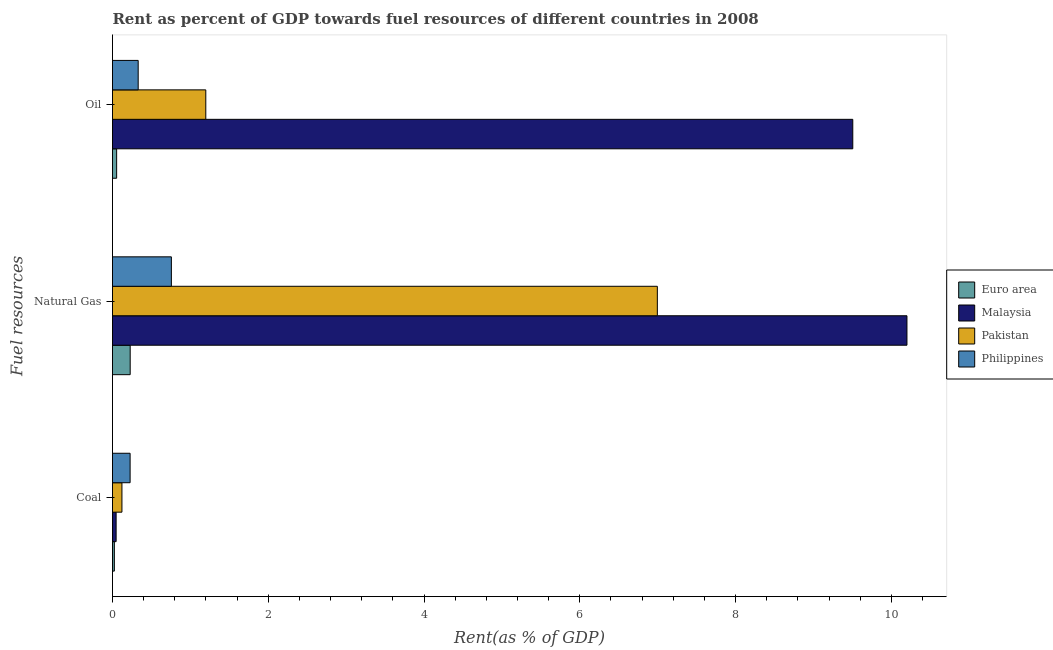How many different coloured bars are there?
Provide a succinct answer. 4. How many groups of bars are there?
Your answer should be very brief. 3. How many bars are there on the 2nd tick from the top?
Your response must be concise. 4. What is the label of the 2nd group of bars from the top?
Keep it short and to the point. Natural Gas. What is the rent towards natural gas in Euro area?
Ensure brevity in your answer.  0.23. Across all countries, what is the maximum rent towards coal?
Offer a terse response. 0.23. Across all countries, what is the minimum rent towards natural gas?
Your answer should be compact. 0.23. In which country was the rent towards natural gas maximum?
Keep it short and to the point. Malaysia. In which country was the rent towards natural gas minimum?
Your response must be concise. Euro area. What is the total rent towards oil in the graph?
Offer a very short reply. 11.09. What is the difference between the rent towards oil in Pakistan and that in Euro area?
Make the answer very short. 1.14. What is the difference between the rent towards oil in Euro area and the rent towards natural gas in Philippines?
Make the answer very short. -0.7. What is the average rent towards natural gas per country?
Ensure brevity in your answer.  4.54. What is the difference between the rent towards oil and rent towards natural gas in Euro area?
Offer a terse response. -0.17. What is the ratio of the rent towards oil in Malaysia to that in Philippines?
Your response must be concise. 28.83. Is the rent towards oil in Malaysia less than that in Euro area?
Ensure brevity in your answer.  No. Is the difference between the rent towards coal in Pakistan and Philippines greater than the difference between the rent towards natural gas in Pakistan and Philippines?
Your response must be concise. No. What is the difference between the highest and the second highest rent towards natural gas?
Your answer should be compact. 3.2. What is the difference between the highest and the lowest rent towards oil?
Your answer should be very brief. 9.45. In how many countries, is the rent towards coal greater than the average rent towards coal taken over all countries?
Keep it short and to the point. 2. Is the sum of the rent towards natural gas in Euro area and Malaysia greater than the maximum rent towards coal across all countries?
Offer a terse response. Yes. What does the 4th bar from the top in Natural Gas represents?
Provide a short and direct response. Euro area. Is it the case that in every country, the sum of the rent towards coal and rent towards natural gas is greater than the rent towards oil?
Provide a succinct answer. Yes. How many countries are there in the graph?
Give a very brief answer. 4. What is the difference between two consecutive major ticks on the X-axis?
Keep it short and to the point. 2. Does the graph contain any zero values?
Keep it short and to the point. No. Does the graph contain grids?
Provide a succinct answer. No. What is the title of the graph?
Keep it short and to the point. Rent as percent of GDP towards fuel resources of different countries in 2008. What is the label or title of the X-axis?
Your answer should be compact. Rent(as % of GDP). What is the label or title of the Y-axis?
Your answer should be compact. Fuel resources. What is the Rent(as % of GDP) of Euro area in Coal?
Your answer should be compact. 0.02. What is the Rent(as % of GDP) in Malaysia in Coal?
Your response must be concise. 0.05. What is the Rent(as % of GDP) of Pakistan in Coal?
Make the answer very short. 0.12. What is the Rent(as % of GDP) of Philippines in Coal?
Your response must be concise. 0.23. What is the Rent(as % of GDP) in Euro area in Natural Gas?
Your answer should be compact. 0.23. What is the Rent(as % of GDP) of Malaysia in Natural Gas?
Ensure brevity in your answer.  10.2. What is the Rent(as % of GDP) in Pakistan in Natural Gas?
Your answer should be compact. 7. What is the Rent(as % of GDP) of Philippines in Natural Gas?
Your answer should be compact. 0.76. What is the Rent(as % of GDP) in Euro area in Oil?
Make the answer very short. 0.05. What is the Rent(as % of GDP) in Malaysia in Oil?
Keep it short and to the point. 9.5. What is the Rent(as % of GDP) in Pakistan in Oil?
Your answer should be very brief. 1.2. What is the Rent(as % of GDP) of Philippines in Oil?
Keep it short and to the point. 0.33. Across all Fuel resources, what is the maximum Rent(as % of GDP) of Euro area?
Make the answer very short. 0.23. Across all Fuel resources, what is the maximum Rent(as % of GDP) in Malaysia?
Provide a succinct answer. 10.2. Across all Fuel resources, what is the maximum Rent(as % of GDP) of Pakistan?
Make the answer very short. 7. Across all Fuel resources, what is the maximum Rent(as % of GDP) of Philippines?
Your answer should be compact. 0.76. Across all Fuel resources, what is the minimum Rent(as % of GDP) of Euro area?
Offer a very short reply. 0.02. Across all Fuel resources, what is the minimum Rent(as % of GDP) of Malaysia?
Your answer should be very brief. 0.05. Across all Fuel resources, what is the minimum Rent(as % of GDP) of Pakistan?
Ensure brevity in your answer.  0.12. Across all Fuel resources, what is the minimum Rent(as % of GDP) of Philippines?
Give a very brief answer. 0.23. What is the total Rent(as % of GDP) of Euro area in the graph?
Offer a very short reply. 0.3. What is the total Rent(as % of GDP) in Malaysia in the graph?
Your answer should be very brief. 19.75. What is the total Rent(as % of GDP) of Pakistan in the graph?
Offer a terse response. 8.31. What is the total Rent(as % of GDP) of Philippines in the graph?
Your answer should be compact. 1.31. What is the difference between the Rent(as % of GDP) in Euro area in Coal and that in Natural Gas?
Provide a short and direct response. -0.2. What is the difference between the Rent(as % of GDP) in Malaysia in Coal and that in Natural Gas?
Your response must be concise. -10.15. What is the difference between the Rent(as % of GDP) in Pakistan in Coal and that in Natural Gas?
Your answer should be very brief. -6.87. What is the difference between the Rent(as % of GDP) of Philippines in Coal and that in Natural Gas?
Give a very brief answer. -0.53. What is the difference between the Rent(as % of GDP) of Euro area in Coal and that in Oil?
Offer a terse response. -0.03. What is the difference between the Rent(as % of GDP) in Malaysia in Coal and that in Oil?
Offer a terse response. -9.46. What is the difference between the Rent(as % of GDP) in Pakistan in Coal and that in Oil?
Provide a succinct answer. -1.08. What is the difference between the Rent(as % of GDP) of Philippines in Coal and that in Oil?
Offer a very short reply. -0.1. What is the difference between the Rent(as % of GDP) of Euro area in Natural Gas and that in Oil?
Your answer should be compact. 0.17. What is the difference between the Rent(as % of GDP) of Malaysia in Natural Gas and that in Oil?
Your response must be concise. 0.7. What is the difference between the Rent(as % of GDP) of Pakistan in Natural Gas and that in Oil?
Your answer should be very brief. 5.8. What is the difference between the Rent(as % of GDP) of Philippines in Natural Gas and that in Oil?
Give a very brief answer. 0.43. What is the difference between the Rent(as % of GDP) in Euro area in Coal and the Rent(as % of GDP) in Malaysia in Natural Gas?
Your answer should be compact. -10.18. What is the difference between the Rent(as % of GDP) of Euro area in Coal and the Rent(as % of GDP) of Pakistan in Natural Gas?
Give a very brief answer. -6.97. What is the difference between the Rent(as % of GDP) in Euro area in Coal and the Rent(as % of GDP) in Philippines in Natural Gas?
Your answer should be very brief. -0.73. What is the difference between the Rent(as % of GDP) in Malaysia in Coal and the Rent(as % of GDP) in Pakistan in Natural Gas?
Provide a succinct answer. -6.95. What is the difference between the Rent(as % of GDP) of Malaysia in Coal and the Rent(as % of GDP) of Philippines in Natural Gas?
Provide a short and direct response. -0.71. What is the difference between the Rent(as % of GDP) in Pakistan in Coal and the Rent(as % of GDP) in Philippines in Natural Gas?
Keep it short and to the point. -0.63. What is the difference between the Rent(as % of GDP) in Euro area in Coal and the Rent(as % of GDP) in Malaysia in Oil?
Your answer should be compact. -9.48. What is the difference between the Rent(as % of GDP) of Euro area in Coal and the Rent(as % of GDP) of Pakistan in Oil?
Provide a short and direct response. -1.17. What is the difference between the Rent(as % of GDP) of Euro area in Coal and the Rent(as % of GDP) of Philippines in Oil?
Your answer should be very brief. -0.31. What is the difference between the Rent(as % of GDP) of Malaysia in Coal and the Rent(as % of GDP) of Pakistan in Oil?
Your answer should be very brief. -1.15. What is the difference between the Rent(as % of GDP) of Malaysia in Coal and the Rent(as % of GDP) of Philippines in Oil?
Keep it short and to the point. -0.28. What is the difference between the Rent(as % of GDP) of Pakistan in Coal and the Rent(as % of GDP) of Philippines in Oil?
Keep it short and to the point. -0.21. What is the difference between the Rent(as % of GDP) in Euro area in Natural Gas and the Rent(as % of GDP) in Malaysia in Oil?
Your response must be concise. -9.28. What is the difference between the Rent(as % of GDP) of Euro area in Natural Gas and the Rent(as % of GDP) of Pakistan in Oil?
Provide a succinct answer. -0.97. What is the difference between the Rent(as % of GDP) in Euro area in Natural Gas and the Rent(as % of GDP) in Philippines in Oil?
Your answer should be compact. -0.1. What is the difference between the Rent(as % of GDP) of Malaysia in Natural Gas and the Rent(as % of GDP) of Pakistan in Oil?
Give a very brief answer. 9. What is the difference between the Rent(as % of GDP) of Malaysia in Natural Gas and the Rent(as % of GDP) of Philippines in Oil?
Give a very brief answer. 9.87. What is the difference between the Rent(as % of GDP) in Pakistan in Natural Gas and the Rent(as % of GDP) in Philippines in Oil?
Your response must be concise. 6.67. What is the average Rent(as % of GDP) in Euro area per Fuel resources?
Offer a very short reply. 0.1. What is the average Rent(as % of GDP) in Malaysia per Fuel resources?
Your answer should be very brief. 6.58. What is the average Rent(as % of GDP) in Pakistan per Fuel resources?
Your answer should be compact. 2.77. What is the average Rent(as % of GDP) of Philippines per Fuel resources?
Your answer should be compact. 0.44. What is the difference between the Rent(as % of GDP) in Euro area and Rent(as % of GDP) in Malaysia in Coal?
Provide a short and direct response. -0.02. What is the difference between the Rent(as % of GDP) of Euro area and Rent(as % of GDP) of Pakistan in Coal?
Your answer should be very brief. -0.1. What is the difference between the Rent(as % of GDP) of Euro area and Rent(as % of GDP) of Philippines in Coal?
Offer a terse response. -0.2. What is the difference between the Rent(as % of GDP) of Malaysia and Rent(as % of GDP) of Pakistan in Coal?
Ensure brevity in your answer.  -0.07. What is the difference between the Rent(as % of GDP) in Malaysia and Rent(as % of GDP) in Philippines in Coal?
Your response must be concise. -0.18. What is the difference between the Rent(as % of GDP) in Pakistan and Rent(as % of GDP) in Philippines in Coal?
Make the answer very short. -0.1. What is the difference between the Rent(as % of GDP) of Euro area and Rent(as % of GDP) of Malaysia in Natural Gas?
Provide a succinct answer. -9.97. What is the difference between the Rent(as % of GDP) in Euro area and Rent(as % of GDP) in Pakistan in Natural Gas?
Your response must be concise. -6.77. What is the difference between the Rent(as % of GDP) in Euro area and Rent(as % of GDP) in Philippines in Natural Gas?
Provide a succinct answer. -0.53. What is the difference between the Rent(as % of GDP) in Malaysia and Rent(as % of GDP) in Pakistan in Natural Gas?
Give a very brief answer. 3.2. What is the difference between the Rent(as % of GDP) in Malaysia and Rent(as % of GDP) in Philippines in Natural Gas?
Your answer should be compact. 9.44. What is the difference between the Rent(as % of GDP) in Pakistan and Rent(as % of GDP) in Philippines in Natural Gas?
Provide a short and direct response. 6.24. What is the difference between the Rent(as % of GDP) of Euro area and Rent(as % of GDP) of Malaysia in Oil?
Your answer should be compact. -9.45. What is the difference between the Rent(as % of GDP) in Euro area and Rent(as % of GDP) in Pakistan in Oil?
Provide a succinct answer. -1.14. What is the difference between the Rent(as % of GDP) of Euro area and Rent(as % of GDP) of Philippines in Oil?
Your answer should be compact. -0.28. What is the difference between the Rent(as % of GDP) of Malaysia and Rent(as % of GDP) of Pakistan in Oil?
Keep it short and to the point. 8.31. What is the difference between the Rent(as % of GDP) in Malaysia and Rent(as % of GDP) in Philippines in Oil?
Provide a succinct answer. 9.18. What is the difference between the Rent(as % of GDP) of Pakistan and Rent(as % of GDP) of Philippines in Oil?
Your response must be concise. 0.87. What is the ratio of the Rent(as % of GDP) in Euro area in Coal to that in Natural Gas?
Ensure brevity in your answer.  0.11. What is the ratio of the Rent(as % of GDP) in Malaysia in Coal to that in Natural Gas?
Provide a succinct answer. 0. What is the ratio of the Rent(as % of GDP) of Pakistan in Coal to that in Natural Gas?
Ensure brevity in your answer.  0.02. What is the ratio of the Rent(as % of GDP) of Philippines in Coal to that in Natural Gas?
Keep it short and to the point. 0.3. What is the ratio of the Rent(as % of GDP) in Euro area in Coal to that in Oil?
Provide a succinct answer. 0.45. What is the ratio of the Rent(as % of GDP) in Malaysia in Coal to that in Oil?
Make the answer very short. 0. What is the ratio of the Rent(as % of GDP) in Pakistan in Coal to that in Oil?
Keep it short and to the point. 0.1. What is the ratio of the Rent(as % of GDP) in Philippines in Coal to that in Oil?
Offer a terse response. 0.69. What is the ratio of the Rent(as % of GDP) in Euro area in Natural Gas to that in Oil?
Your response must be concise. 4.27. What is the ratio of the Rent(as % of GDP) of Malaysia in Natural Gas to that in Oil?
Provide a short and direct response. 1.07. What is the ratio of the Rent(as % of GDP) in Pakistan in Natural Gas to that in Oil?
Provide a succinct answer. 5.84. What is the ratio of the Rent(as % of GDP) of Philippines in Natural Gas to that in Oil?
Give a very brief answer. 2.29. What is the difference between the highest and the second highest Rent(as % of GDP) of Euro area?
Provide a short and direct response. 0.17. What is the difference between the highest and the second highest Rent(as % of GDP) of Malaysia?
Offer a very short reply. 0.7. What is the difference between the highest and the second highest Rent(as % of GDP) in Pakistan?
Provide a succinct answer. 5.8. What is the difference between the highest and the second highest Rent(as % of GDP) in Philippines?
Provide a short and direct response. 0.43. What is the difference between the highest and the lowest Rent(as % of GDP) of Euro area?
Ensure brevity in your answer.  0.2. What is the difference between the highest and the lowest Rent(as % of GDP) of Malaysia?
Your answer should be compact. 10.15. What is the difference between the highest and the lowest Rent(as % of GDP) of Pakistan?
Offer a terse response. 6.87. What is the difference between the highest and the lowest Rent(as % of GDP) of Philippines?
Your response must be concise. 0.53. 